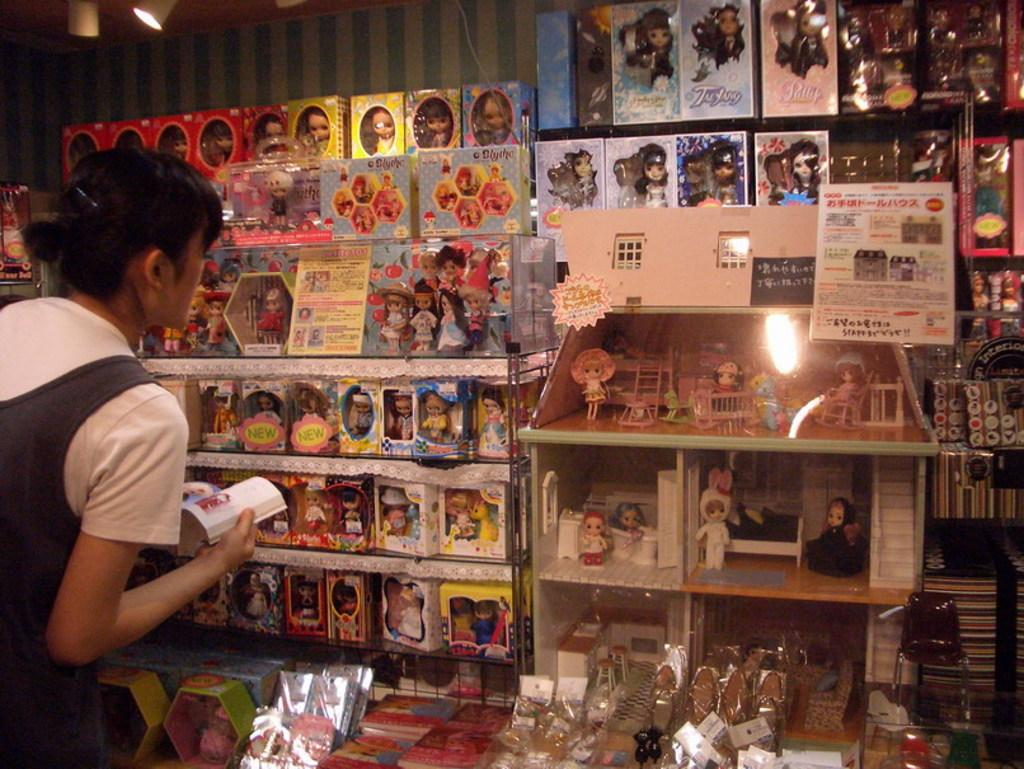What is the person in the image doing? The person is standing in the image and holding a book. What else can be seen in the image besides the person? There are toys, papers, and other objects present in the image. Can you describe the toys in the image? Unfortunately, the facts provided do not give specific details about the toys. What might the person be using the papers for in the image? The purpose of the papers cannot be determined from the provided facts. What type of cake is being served at the party in the image? There is no party or cake present in the image; it features a person holding a book and other objects. What is the person wishing for as they hold the book in the image? There is no indication in the image that the person is making a wish while holding the book. 